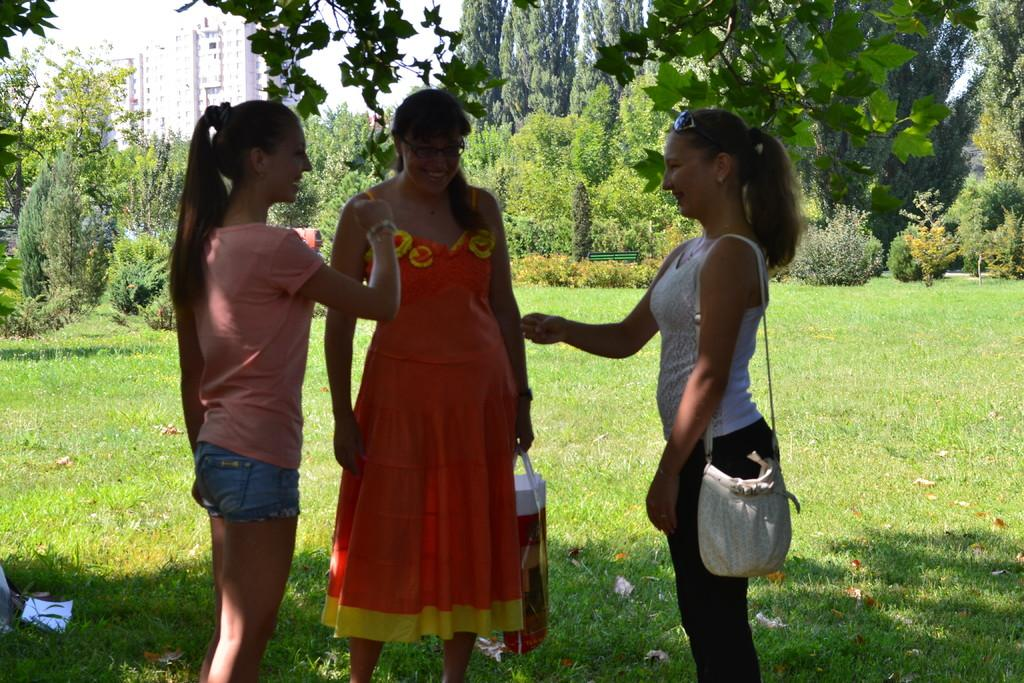What type of vegetation can be seen in the image? There is grass, plants, and trees in the image. How many people are visible in the image? There are two people standing in the front of the image. What structures can be seen in the image? There are buildings in the image. What type of memory is stored in the room depicted in the image? There is no room present in the image, so it is not possible to determine what type of memory might be stored there. 